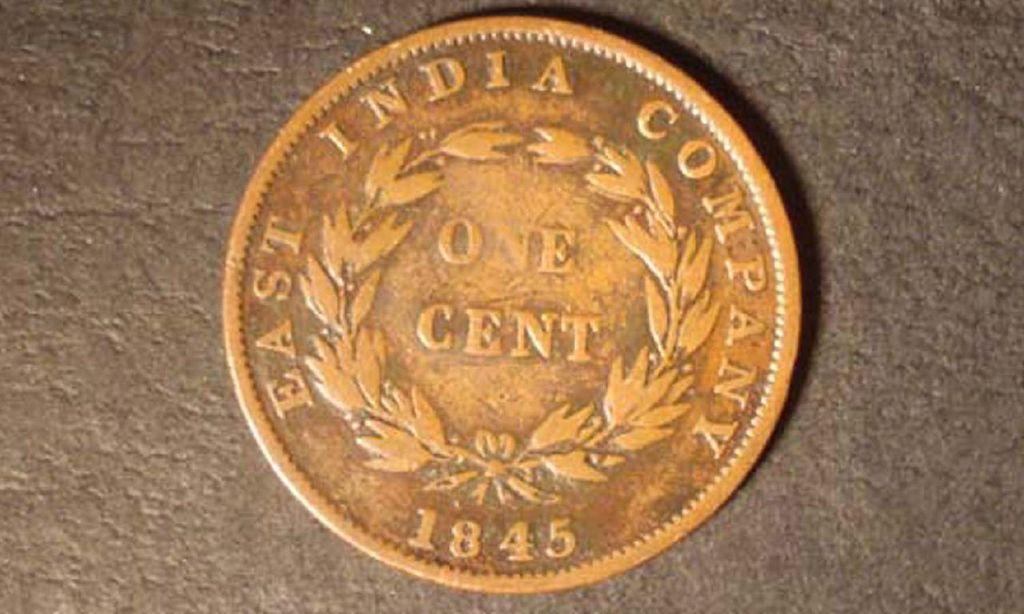<image>
Summarize the visual content of the image. A one cent piece from 1845 lays on a stone background and reads "East India Company." 